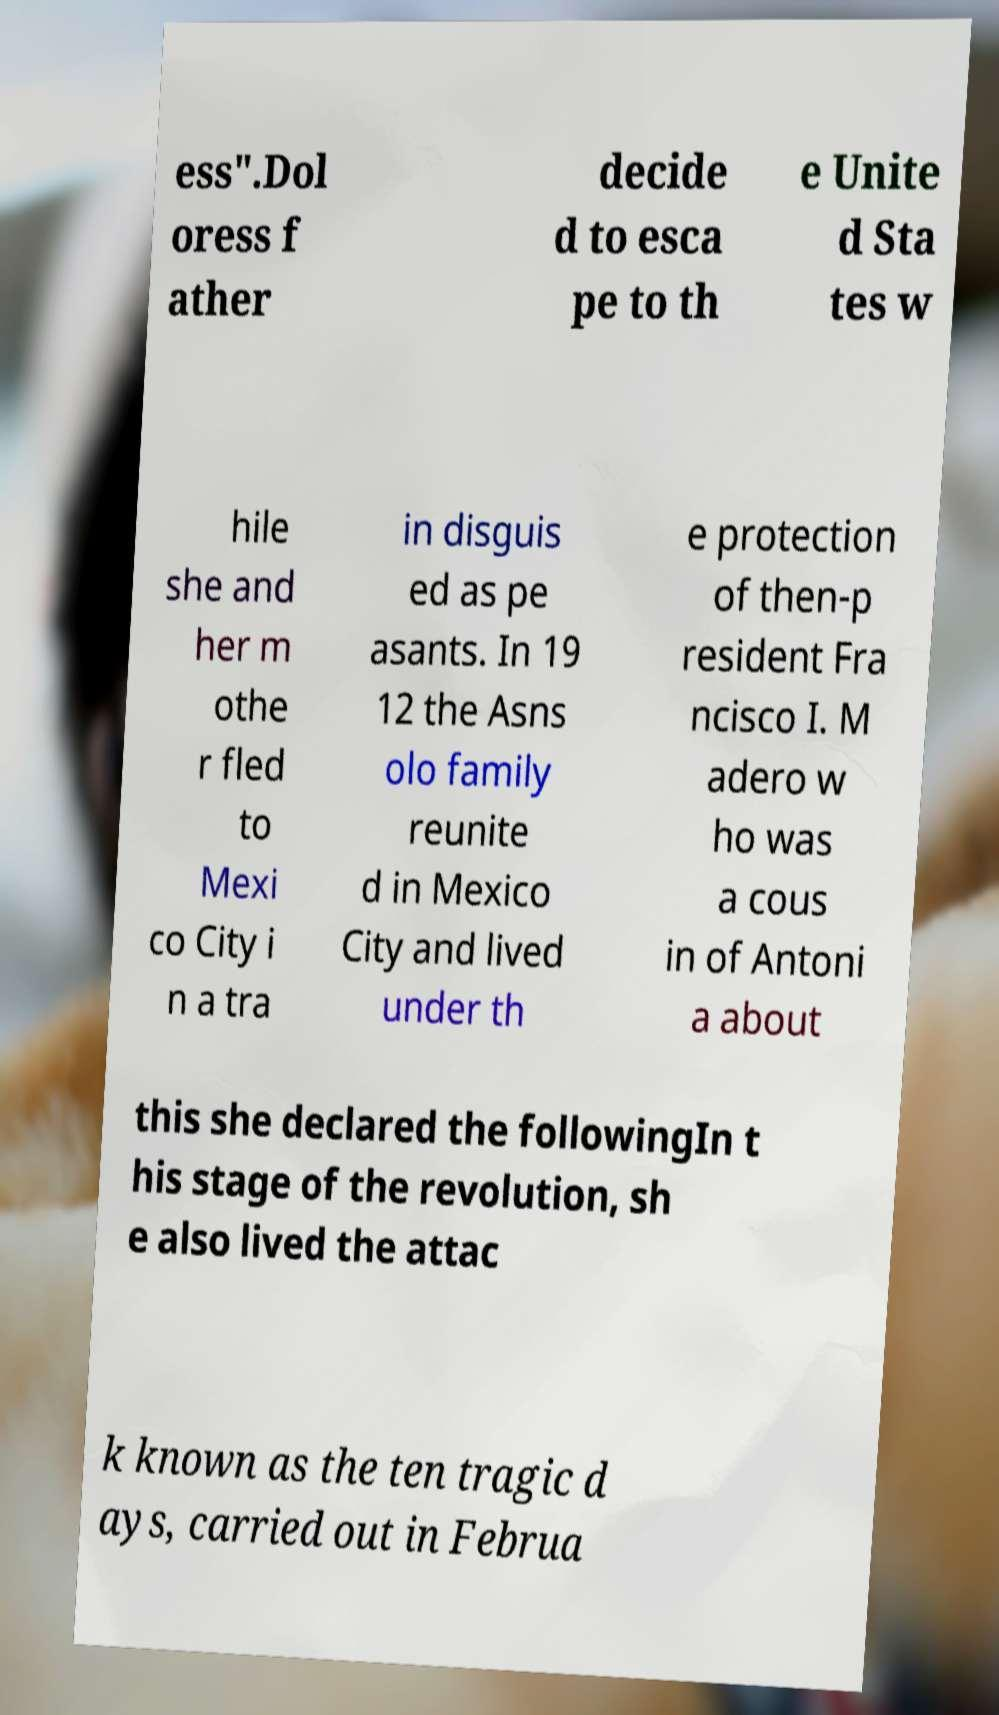What messages or text are displayed in this image? I need them in a readable, typed format. ess".Dol oress f ather decide d to esca pe to th e Unite d Sta tes w hile she and her m othe r fled to Mexi co City i n a tra in disguis ed as pe asants. In 19 12 the Asns olo family reunite d in Mexico City and lived under th e protection of then-p resident Fra ncisco I. M adero w ho was a cous in of Antoni a about this she declared the followingIn t his stage of the revolution, sh e also lived the attac k known as the ten tragic d ays, carried out in Februa 